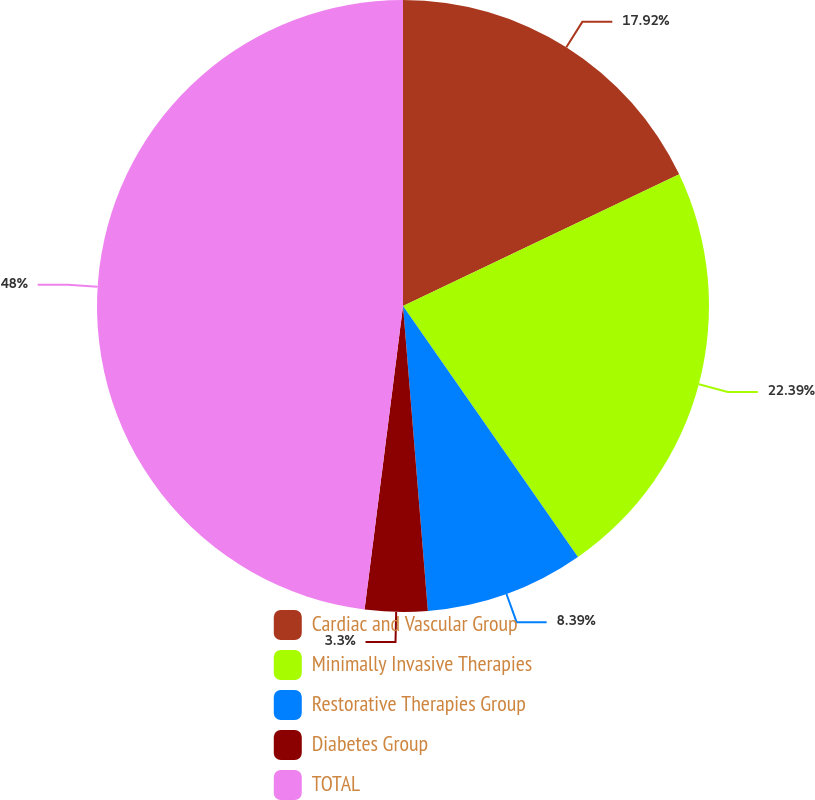Convert chart to OTSL. <chart><loc_0><loc_0><loc_500><loc_500><pie_chart><fcel>Cardiac and Vascular Group<fcel>Minimally Invasive Therapies<fcel>Restorative Therapies Group<fcel>Diabetes Group<fcel>TOTAL<nl><fcel>17.92%<fcel>22.39%<fcel>8.39%<fcel>3.3%<fcel>47.99%<nl></chart> 